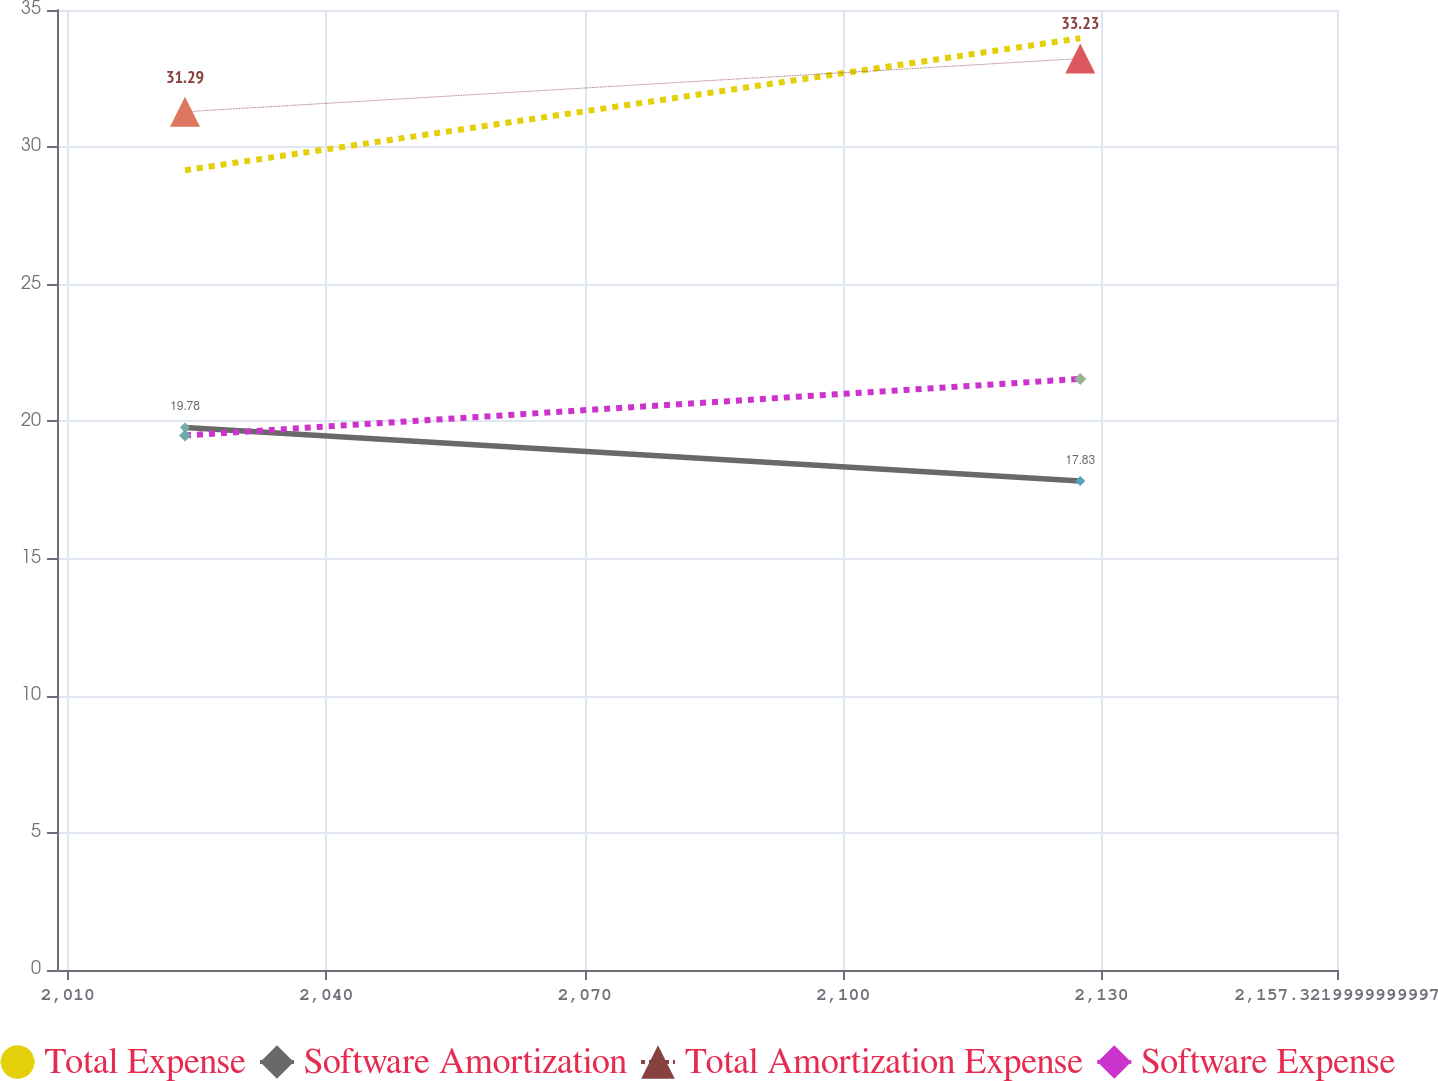Convert chart to OTSL. <chart><loc_0><loc_0><loc_500><loc_500><line_chart><ecel><fcel>Total Expense<fcel>Software Amortization<fcel>Total Amortization Expense<fcel>Software Expense<nl><fcel>2023.6<fcel>29.16<fcel>19.78<fcel>31.29<fcel>19.49<nl><fcel>2127.52<fcel>33.97<fcel>17.83<fcel>33.23<fcel>21.55<nl><fcel>2172.18<fcel>32.31<fcel>23.64<fcel>31.07<fcel>19.79<nl></chart> 